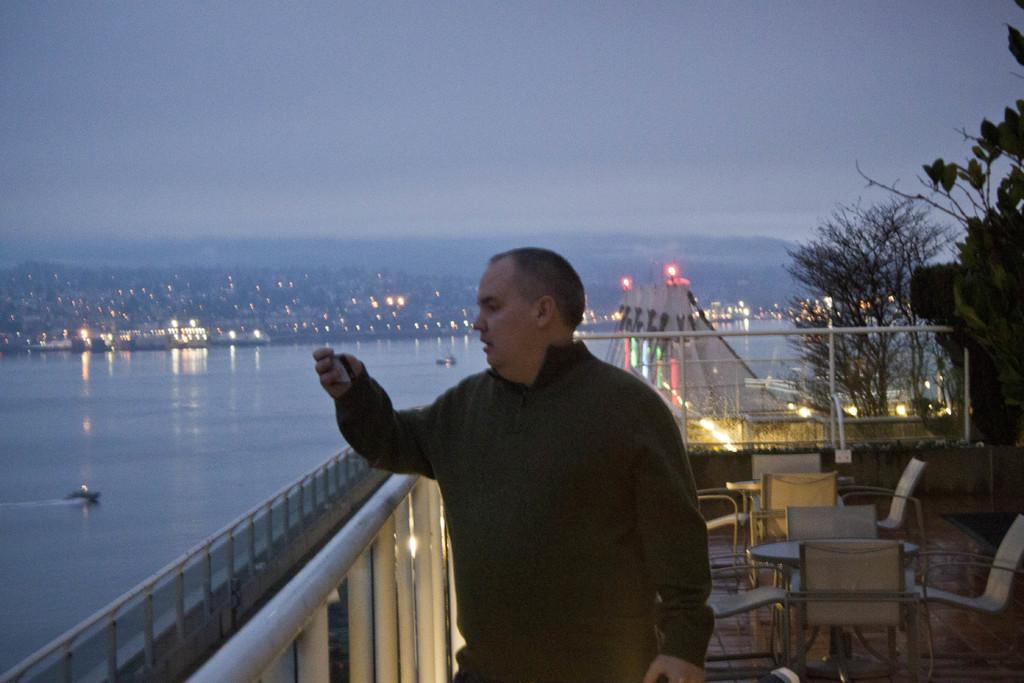What is the main subject of the image? There is a person standing in the image. What can be seen in the background of the image? There is a beautiful tree, lighting, a sea, and the sky visible in the background of the image. Can you see any horses in the image? There are no horses present in the image. Is the person in the image traveling through space? There is no indication of space travel in the image; it features a person standing near a beautiful tree, lighting, a sea, and the sky. 